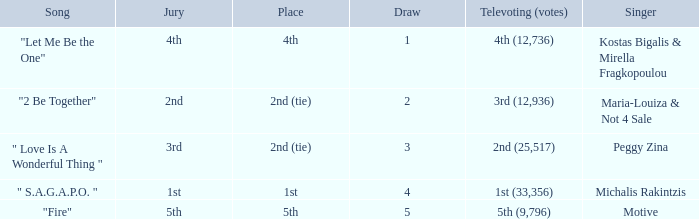What jury was involved with singer maria-louiza & not 4 sale? 2nd. 